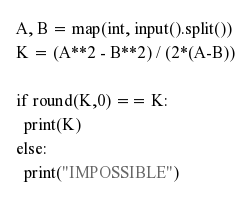Convert code to text. <code><loc_0><loc_0><loc_500><loc_500><_Python_>A, B = map(int, input().split())
K = (A**2 - B**2) / (2*(A-B))

if round(K,0) == K:
  print(K)
else:
  print("IMPOSSIBLE")</code> 